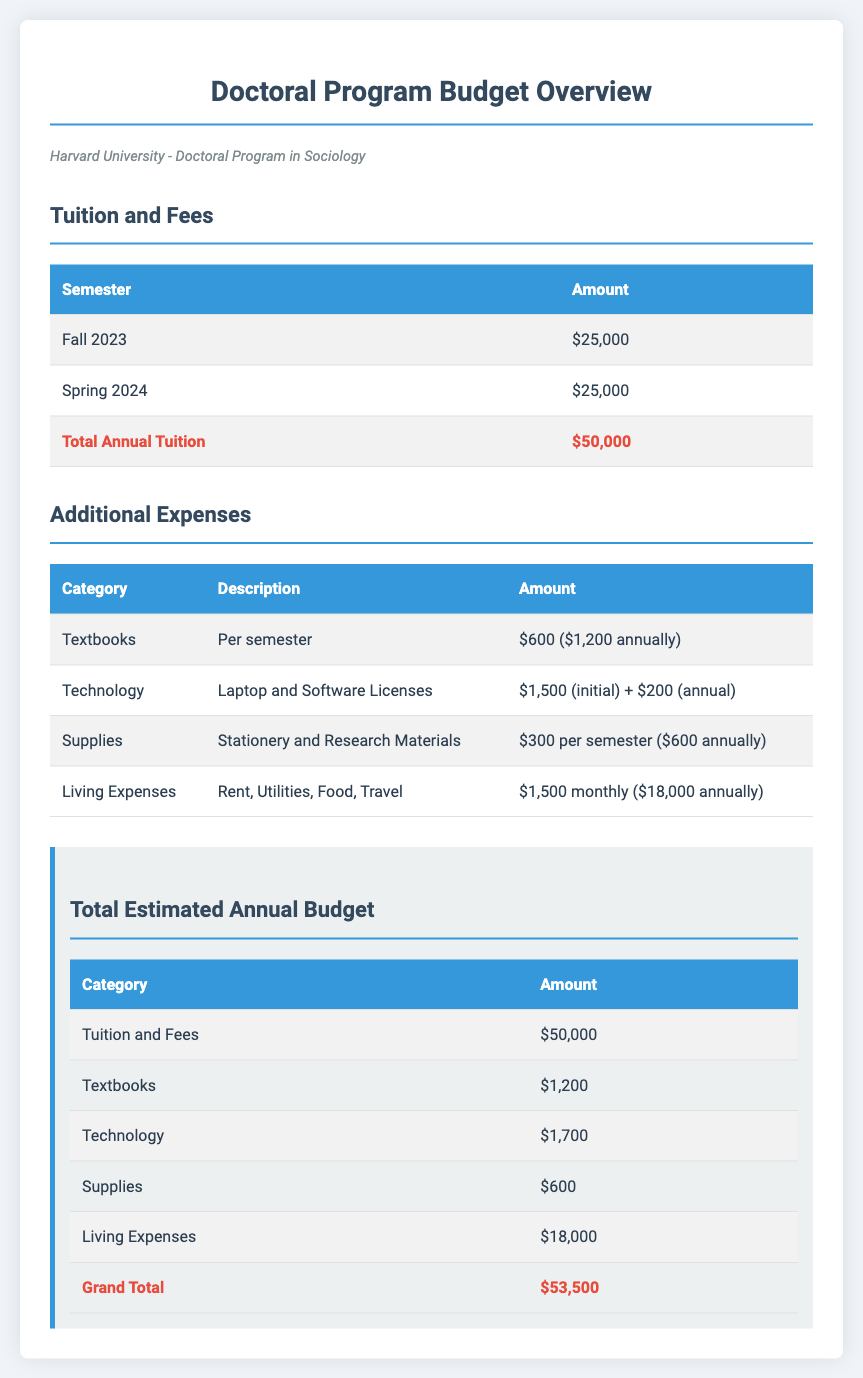What is the tuition for Fall 2023? The tuition for Fall 2023 is listed as $25,000 in the document.
Answer: $25,000 How much are the textbooks per semester? The document states that textbooks cost $600 per semester.
Answer: $600 What is the total estimated annual budget? The total estimated annual budget is summarized at the end of the document as the grand total of all expenses, which is $53,500.
Answer: $53,500 What is the cost of living expenses per month? Living expenses are stated as $1,500 monthly in the budget overview.
Answer: $1,500 How much are technology costs in total? The document details that technology costs include $1,500 initial and $200 annual, totaling $1,700.
Answer: $1,700 What is the total annual tuition? The total annual tuition is provided as a sum of each semester's tuition, which is $50,000.
Answer: $50,000 Which category has the highest cost? The highest cost category in the estimated budget is tuition and fees, amounting to $50,000.
Answer: Tuition and Fees How much are supplies per semester? Supplies are indicated as costing $300 per semester in the document.
Answer: $300 What is the total annual cost for supplies? The total annual cost for supplies is shown to be $600 in the summary.
Answer: $600 